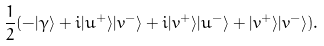Convert formula to latex. <formula><loc_0><loc_0><loc_500><loc_500>\frac { 1 } { 2 } ( - | \gamma \rangle + i | u ^ { + } \rangle | v ^ { - } \rangle + i | v ^ { + } \rangle | u ^ { - } \rangle + | v ^ { + } \rangle | v ^ { - } \rangle ) .</formula> 